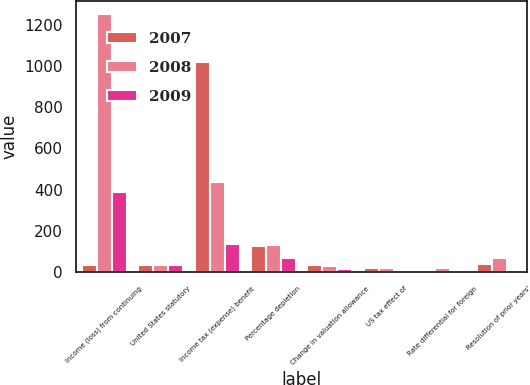<chart> <loc_0><loc_0><loc_500><loc_500><stacked_bar_chart><ecel><fcel>Income (loss) from continuing<fcel>United States statutory<fcel>Income tax (expense) benefit<fcel>Percentage depletion<fcel>Change in valuation allowance<fcel>US tax effect of<fcel>Rate differential for foreign<fcel>Resolution of prior years'<nl><fcel>2007<fcel>35<fcel>35<fcel>1020<fcel>127<fcel>32<fcel>18<fcel>4<fcel>38<nl><fcel>2008<fcel>1252<fcel>35<fcel>438<fcel>130<fcel>31<fcel>19<fcel>20<fcel>69<nl><fcel>2009<fcel>389<fcel>35<fcel>136<fcel>70<fcel>17<fcel>4<fcel>7<fcel>3<nl></chart> 